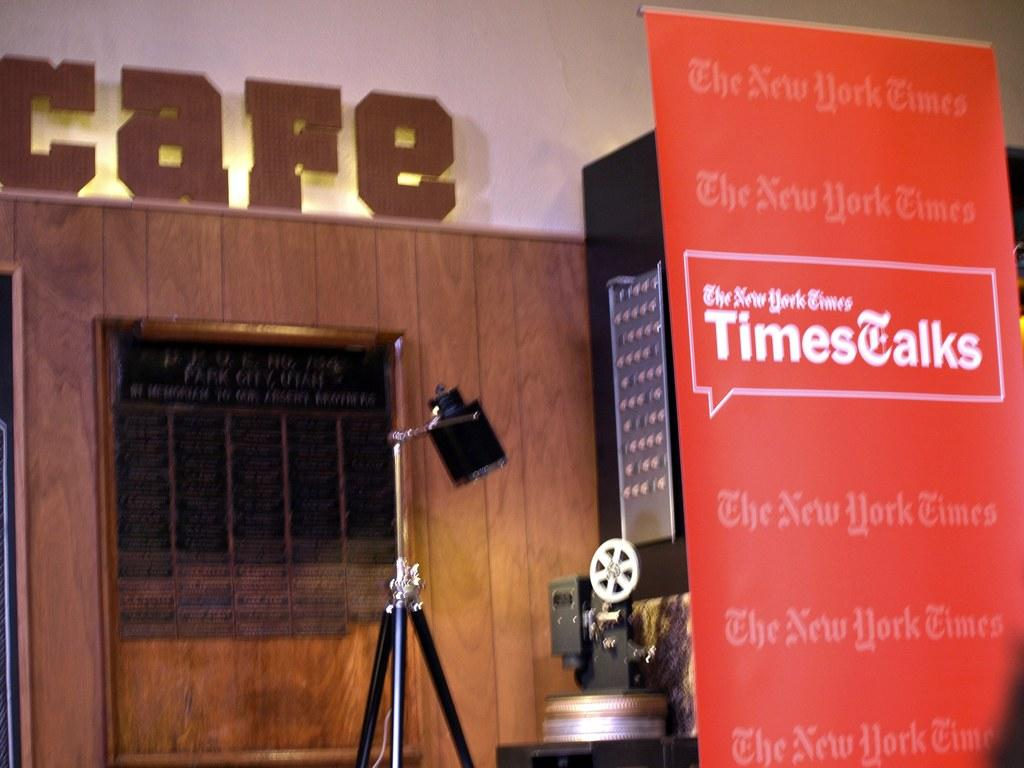What is located on the right side of the image? There is a banner on the right side of the image. What type of equipment is visible in the image? There is a camera and a camera stand in the image. What can be seen in the background of the image? There is a wooden wall in the background of the image. Is there a lift present on the stage in the image? There is no stage or lift present in the image. What form does the wooden wall take in the image? The wooden wall is a solid, flat surface in the background of the image. 